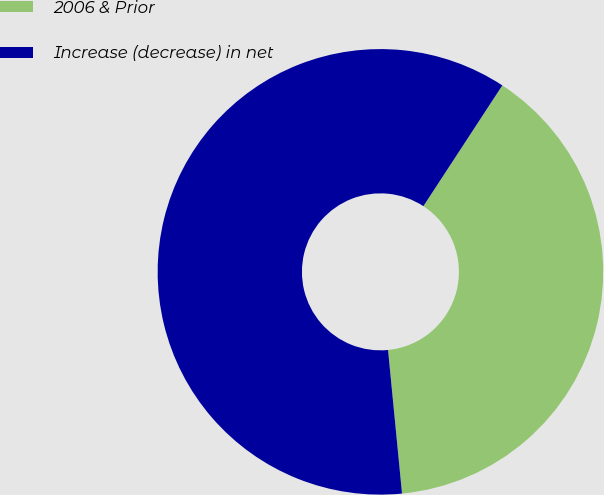Convert chart to OTSL. <chart><loc_0><loc_0><loc_500><loc_500><pie_chart><fcel>2006 & Prior<fcel>Increase (decrease) in net<nl><fcel>39.24%<fcel>60.76%<nl></chart> 